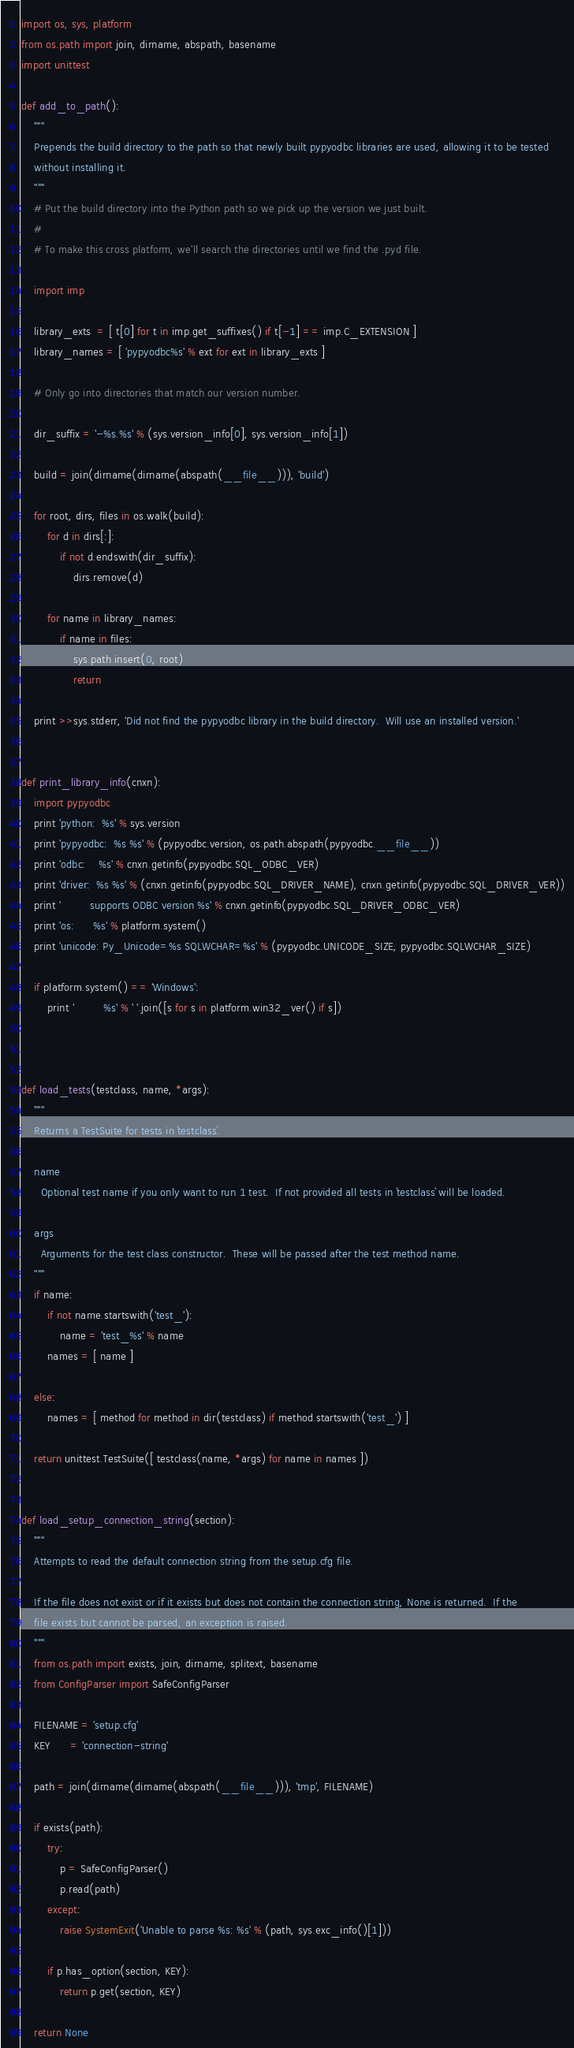Convert code to text. <code><loc_0><loc_0><loc_500><loc_500><_Python_>
import os, sys, platform
from os.path import join, dirname, abspath, basename
import unittest

def add_to_path():
    """
    Prepends the build directory to the path so that newly built pypyodbc libraries are used, allowing it to be tested
    without installing it.
    """
    # Put the build directory into the Python path so we pick up the version we just built.
    #
    # To make this cross platform, we'll search the directories until we find the .pyd file.

    import imp

    library_exts  = [ t[0] for t in imp.get_suffixes() if t[-1] == imp.C_EXTENSION ]
    library_names = [ 'pypyodbc%s' % ext for ext in library_exts ]

    # Only go into directories that match our version number. 

    dir_suffix = '-%s.%s' % (sys.version_info[0], sys.version_info[1])

    build = join(dirname(dirname(abspath(__file__))), 'build')

    for root, dirs, files in os.walk(build):
        for d in dirs[:]:
            if not d.endswith(dir_suffix):
                dirs.remove(d)

        for name in library_names:
            if name in files:
                sys.path.insert(0, root)
                return
                
    print >>sys.stderr, 'Did not find the pypyodbc library in the build directory.  Will use an installed version.'


def print_library_info(cnxn):
    import pypyodbc
    print 'python:  %s' % sys.version
    print 'pypyodbc:  %s %s' % (pypyodbc.version, os.path.abspath(pypyodbc.__file__))
    print 'odbc:    %s' % cnxn.getinfo(pypyodbc.SQL_ODBC_VER)
    print 'driver:  %s %s' % (cnxn.getinfo(pypyodbc.SQL_DRIVER_NAME), cnxn.getinfo(pypyodbc.SQL_DRIVER_VER))
    print '         supports ODBC version %s' % cnxn.getinfo(pypyodbc.SQL_DRIVER_ODBC_VER)
    print 'os:      %s' % platform.system()
    print 'unicode: Py_Unicode=%s SQLWCHAR=%s' % (pypyodbc.UNICODE_SIZE, pypyodbc.SQLWCHAR_SIZE)

    if platform.system() == 'Windows':
        print '         %s' % ' '.join([s for s in platform.win32_ver() if s])



def load_tests(testclass, name, *args):
    """
    Returns a TestSuite for tests in `testclass`.

    name
      Optional test name if you only want to run 1 test.  If not provided all tests in `testclass` will be loaded.

    args
      Arguments for the test class constructor.  These will be passed after the test method name.
    """
    if name:
        if not name.startswith('test_'):
            name = 'test_%s' % name
        names = [ name ]

    else:
        names = [ method for method in dir(testclass) if method.startswith('test_') ]

    return unittest.TestSuite([ testclass(name, *args) for name in names ])


def load_setup_connection_string(section):
    """
    Attempts to read the default connection string from the setup.cfg file.

    If the file does not exist or if it exists but does not contain the connection string, None is returned.  If the
    file exists but cannot be parsed, an exception is raised.
    """
    from os.path import exists, join, dirname, splitext, basename
    from ConfigParser import SafeConfigParser
    
    FILENAME = 'setup.cfg'
    KEY      = 'connection-string'

    path = join(dirname(dirname(abspath(__file__))), 'tmp', FILENAME)

    if exists(path):
        try:
            p = SafeConfigParser()
            p.read(path)
        except:
            raise SystemExit('Unable to parse %s: %s' % (path, sys.exc_info()[1]))

        if p.has_option(section, KEY):
            return p.get(section, KEY)

    return None
</code> 